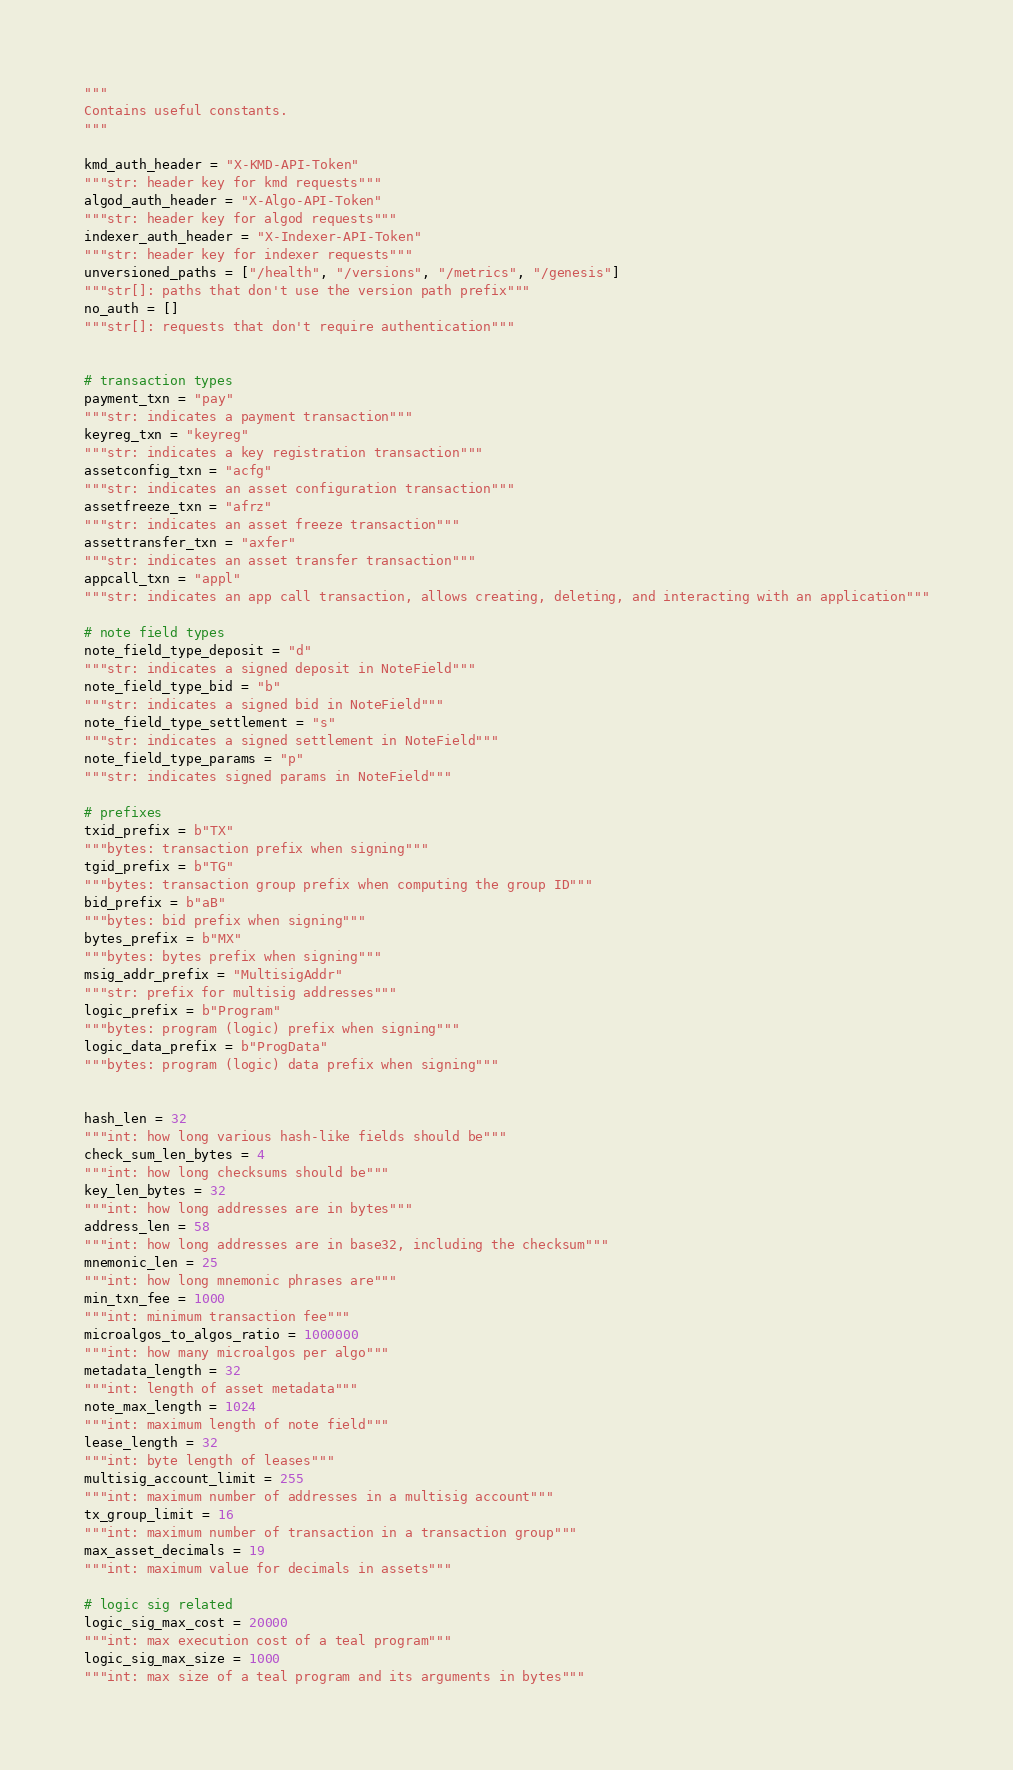Convert code to text. <code><loc_0><loc_0><loc_500><loc_500><_Python_>"""
Contains useful constants.
"""

kmd_auth_header = "X-KMD-API-Token"
"""str: header key for kmd requests"""
algod_auth_header = "X-Algo-API-Token"
"""str: header key for algod requests"""
indexer_auth_header = "X-Indexer-API-Token"
"""str: header key for indexer requests"""
unversioned_paths = ["/health", "/versions", "/metrics", "/genesis"]
"""str[]: paths that don't use the version path prefix"""
no_auth = []
"""str[]: requests that don't require authentication"""


# transaction types
payment_txn = "pay"
"""str: indicates a payment transaction"""
keyreg_txn = "keyreg"
"""str: indicates a key registration transaction"""
assetconfig_txn = "acfg"
"""str: indicates an asset configuration transaction"""
assetfreeze_txn = "afrz"
"""str: indicates an asset freeze transaction"""
assettransfer_txn = "axfer"
"""str: indicates an asset transfer transaction"""
appcall_txn = "appl"
"""str: indicates an app call transaction, allows creating, deleting, and interacting with an application"""

# note field types
note_field_type_deposit = "d"
"""str: indicates a signed deposit in NoteField"""
note_field_type_bid = "b"
"""str: indicates a signed bid in NoteField"""
note_field_type_settlement = "s"
"""str: indicates a signed settlement in NoteField"""
note_field_type_params = "p"
"""str: indicates signed params in NoteField"""

# prefixes
txid_prefix = b"TX"
"""bytes: transaction prefix when signing"""
tgid_prefix = b"TG"
"""bytes: transaction group prefix when computing the group ID"""
bid_prefix = b"aB"
"""bytes: bid prefix when signing"""
bytes_prefix = b"MX"
"""bytes: bytes prefix when signing"""
msig_addr_prefix = "MultisigAddr"
"""str: prefix for multisig addresses"""
logic_prefix = b"Program"
"""bytes: program (logic) prefix when signing"""
logic_data_prefix = b"ProgData"
"""bytes: program (logic) data prefix when signing"""


hash_len = 32
"""int: how long various hash-like fields should be"""
check_sum_len_bytes = 4
"""int: how long checksums should be"""
key_len_bytes = 32
"""int: how long addresses are in bytes"""
address_len = 58
"""int: how long addresses are in base32, including the checksum"""
mnemonic_len = 25
"""int: how long mnemonic phrases are"""
min_txn_fee = 1000
"""int: minimum transaction fee"""
microalgos_to_algos_ratio = 1000000
"""int: how many microalgos per algo"""
metadata_length = 32
"""int: length of asset metadata"""
note_max_length = 1024
"""int: maximum length of note field"""
lease_length = 32
"""int: byte length of leases"""
multisig_account_limit = 255
"""int: maximum number of addresses in a multisig account"""
tx_group_limit = 16
"""int: maximum number of transaction in a transaction group"""
max_asset_decimals = 19
"""int: maximum value for decimals in assets"""

# logic sig related
logic_sig_max_cost = 20000
"""int: max execution cost of a teal program"""
logic_sig_max_size = 1000
"""int: max size of a teal program and its arguments in bytes"""
</code> 